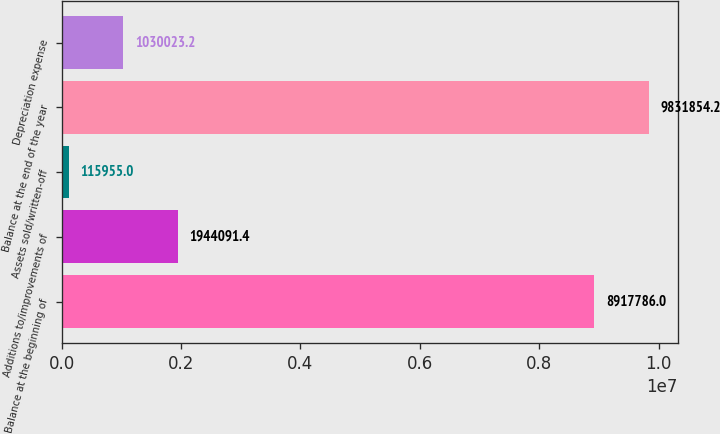Convert chart to OTSL. <chart><loc_0><loc_0><loc_500><loc_500><bar_chart><fcel>Balance at the beginning of<fcel>Additions to/improvements of<fcel>Assets sold/written-off<fcel>Balance at the end of the year<fcel>Depreciation expense<nl><fcel>8.91779e+06<fcel>1.94409e+06<fcel>115955<fcel>9.83185e+06<fcel>1.03002e+06<nl></chart> 